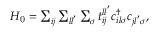<formula> <loc_0><loc_0><loc_500><loc_500>\begin{array} { r } { H _ { 0 } = \sum _ { i j } \sum _ { l l ^ { ^ { \prime } } } \sum _ { \sigma } t _ { i j } ^ { l l ^ { ^ { \prime } } } c _ { i l \sigma } ^ { \dagger } c _ { j l ^ { ^ { \prime } } \sigma } , } \end{array}</formula> 